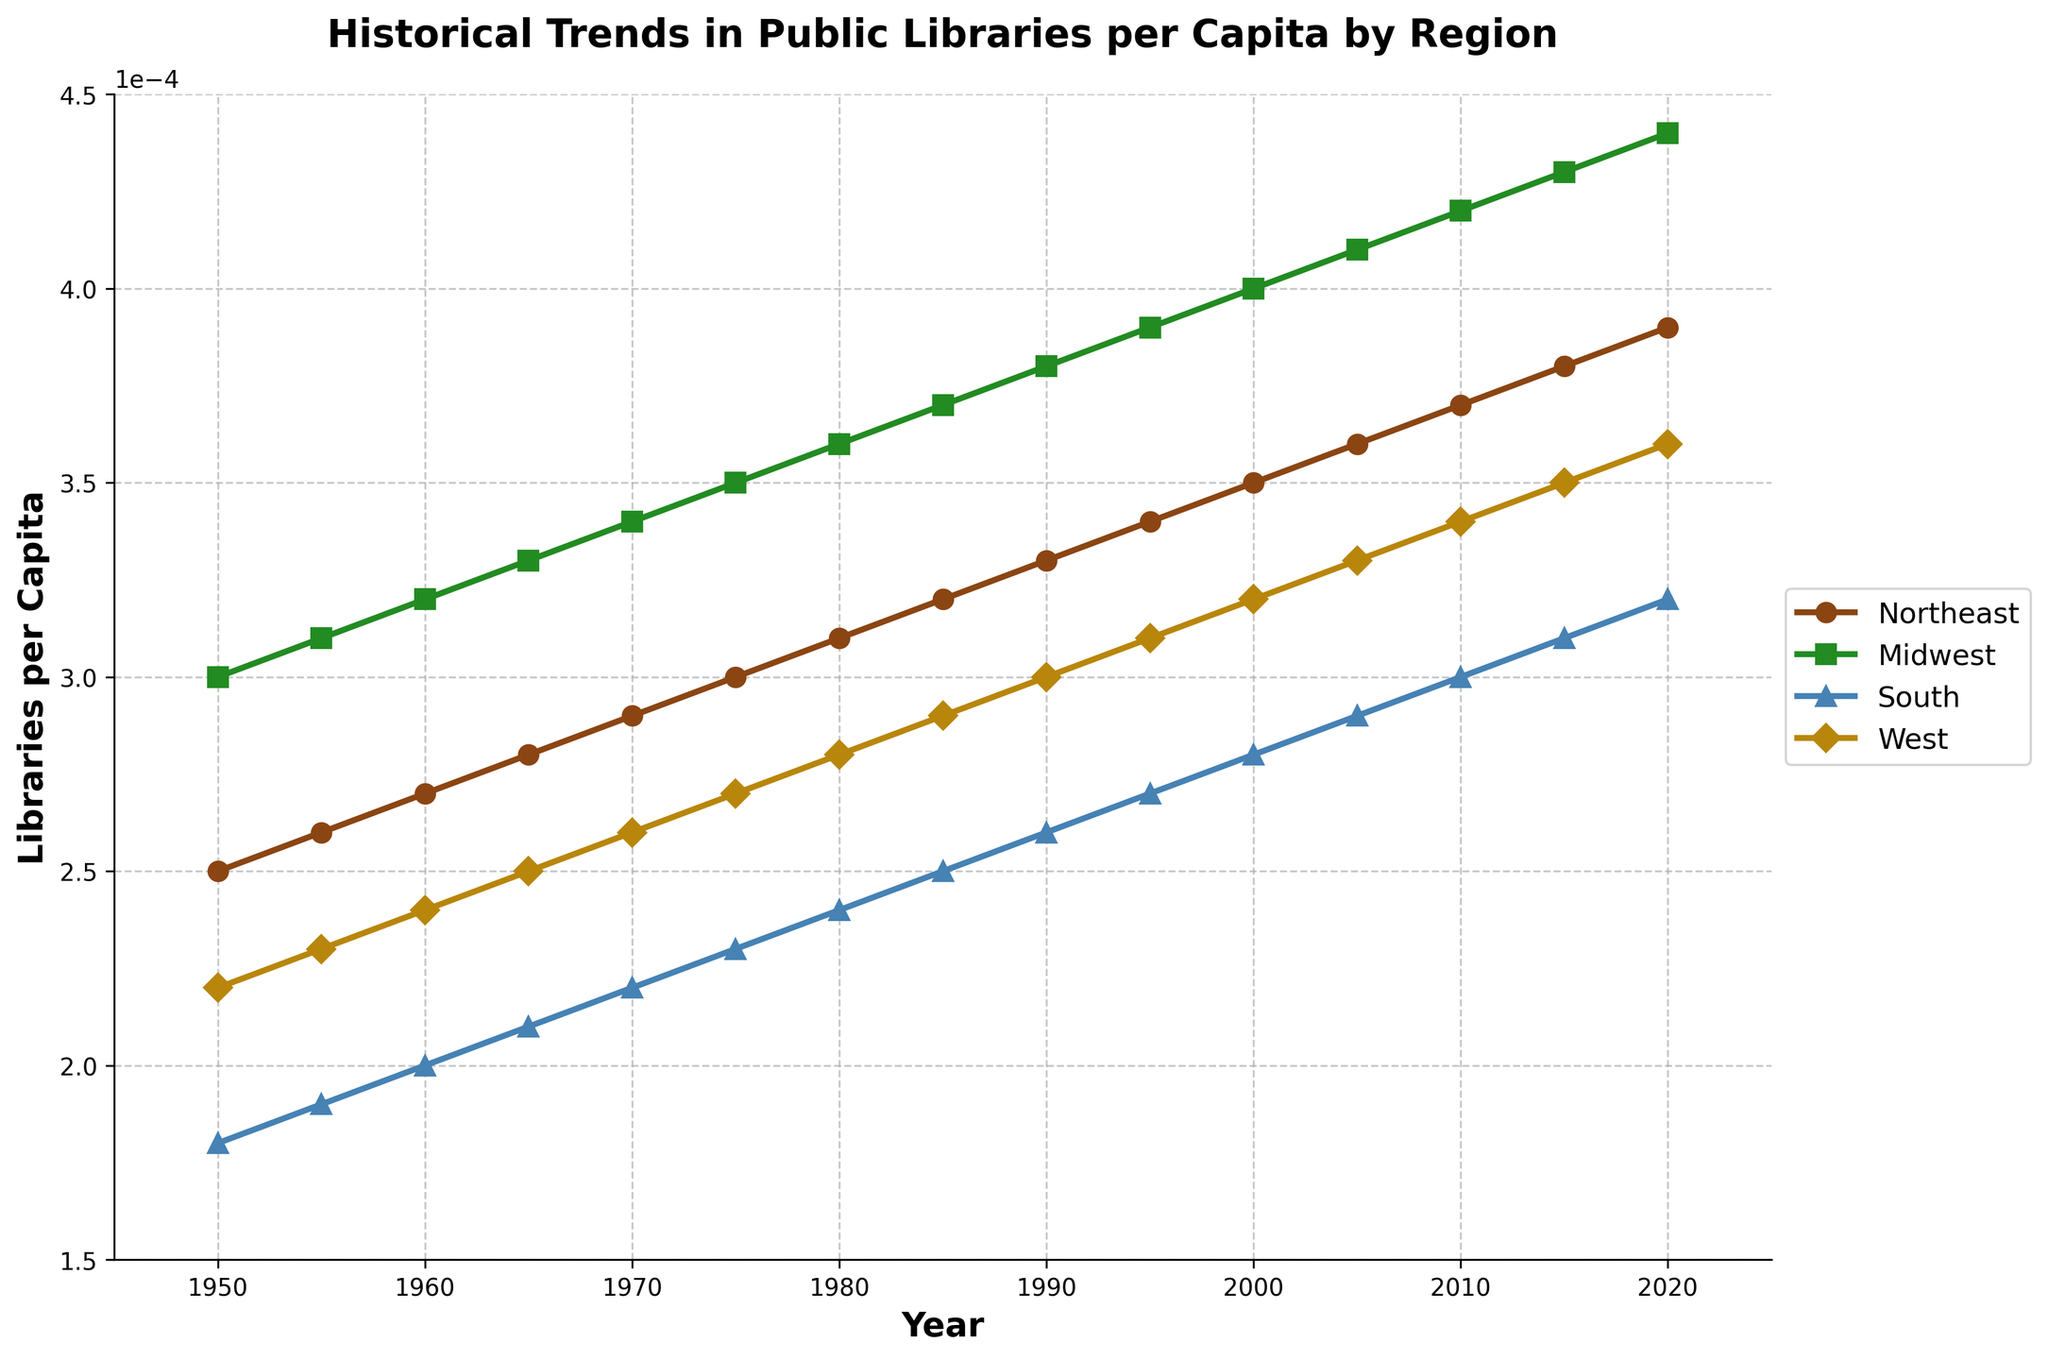Who had the highest number of libraries in 1975? In 1975, the Midwest had the highest number of libraries per capita. This can be observed by looking at the plots for the year 1975, where the Midwest's line is higher than the other regions.
Answer: Midwest Which region shows the slowest growth in libraries per capita from 1950 to 2020? From 1950 to 2020, the South shows the slowest growth in libraries per capita as its line has the smallest slope compared to the other regions.
Answer: South What is the difference in the number of libraries per capita between the Northeast and the West in 2020? In 2020, the number of libraries per capita in the Northeast is 0.00039 and in the West is 0.00036. The difference is 0.00039 - 0.00036.
Answer: 0.00003 What is the average number of libraries per capita in the Midwest over the decades? First, sum up the values for each decade in the Midwest (0.00030+0.00031+0.00032+0.00033+0.00034+0.00035+0.00036+0.00037+0.00038+0.00039+0.00040+0.00041+0.00042+0.00043+0.00044) which is 0.6085 and then divide by 15.
Answer: 0.000040567 Which region had a steeper increase in libraries per capita between 1960 and 1980, the Northeast or the South? From 1960 to 1980, the Northeast increased from 0.00027 to 0.00031 while the South increased from 0.00020 to 0.00024. Calculating the increase, Northeast: 0.00031 - 0.00027 = 0.00004, South: 0.00024 - 0.00020 = 0.00004, thus both had the same increase.
Answer: Both had the same increase Which marker corresponds to the West region? The line representing the West region has a diamond (D) marker, consistent use of visual identification across different years verifies this.
Answer: Diamond What was the median number of libraries per capita in 2005 across all regions? First, list the values for all regions in 2005: (0.00036, 0.00041, 0.00029, 0.00033). The median value is the average of the second and third values when sorted (0.00036, 0.00033) = (0.00033 + 0.00036) / 2.
Answer: 0.000345 In what year did the Midwest surpass 0.00035 libraries per capita? By examining the plot for the Midwest, one can see that the line surpasses 0.00035 libraries per capita between 1975 and 1980. This occurs exactly in 1975.
Answer: 1975 Do any regions have their highest value in 2015? Comparing all regions' values in 2015: Northeast 0.00038, Midwest 0.00043, South 0.00031, and West 0.00035, no region reaches their highest value in 2015. Each region's value continues to increase in 2020.
Answer: No 